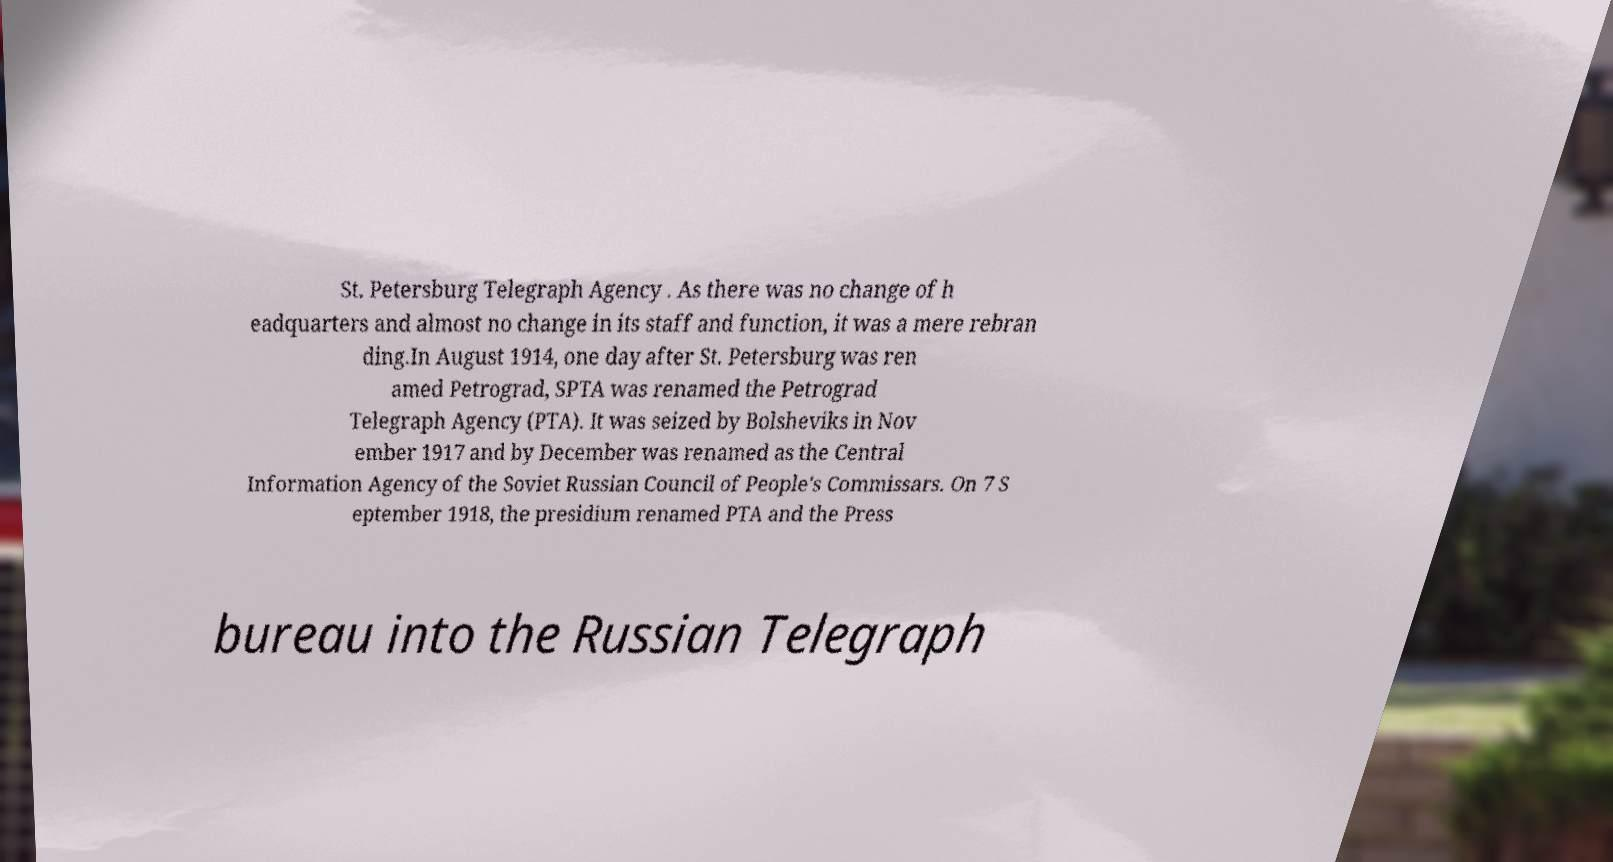Please identify and transcribe the text found in this image. St. Petersburg Telegraph Agency . As there was no change of h eadquarters and almost no change in its staff and function, it was a mere rebran ding.In August 1914, one day after St. Petersburg was ren amed Petrograd, SPTA was renamed the Petrograd Telegraph Agency (PTA). It was seized by Bolsheviks in Nov ember 1917 and by December was renamed as the Central Information Agency of the Soviet Russian Council of People's Commissars. On 7 S eptember 1918, the presidium renamed PTA and the Press bureau into the Russian Telegraph 